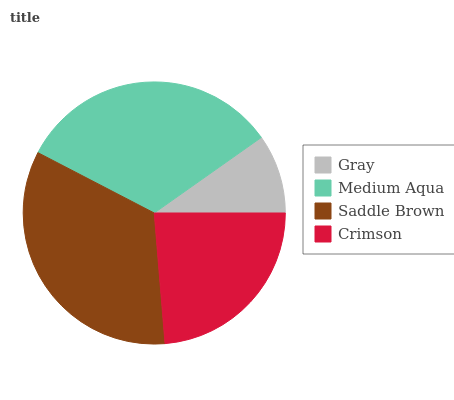Is Gray the minimum?
Answer yes or no. Yes. Is Saddle Brown the maximum?
Answer yes or no. Yes. Is Medium Aqua the minimum?
Answer yes or no. No. Is Medium Aqua the maximum?
Answer yes or no. No. Is Medium Aqua greater than Gray?
Answer yes or no. Yes. Is Gray less than Medium Aqua?
Answer yes or no. Yes. Is Gray greater than Medium Aqua?
Answer yes or no. No. Is Medium Aqua less than Gray?
Answer yes or no. No. Is Medium Aqua the high median?
Answer yes or no. Yes. Is Crimson the low median?
Answer yes or no. Yes. Is Gray the high median?
Answer yes or no. No. Is Saddle Brown the low median?
Answer yes or no. No. 